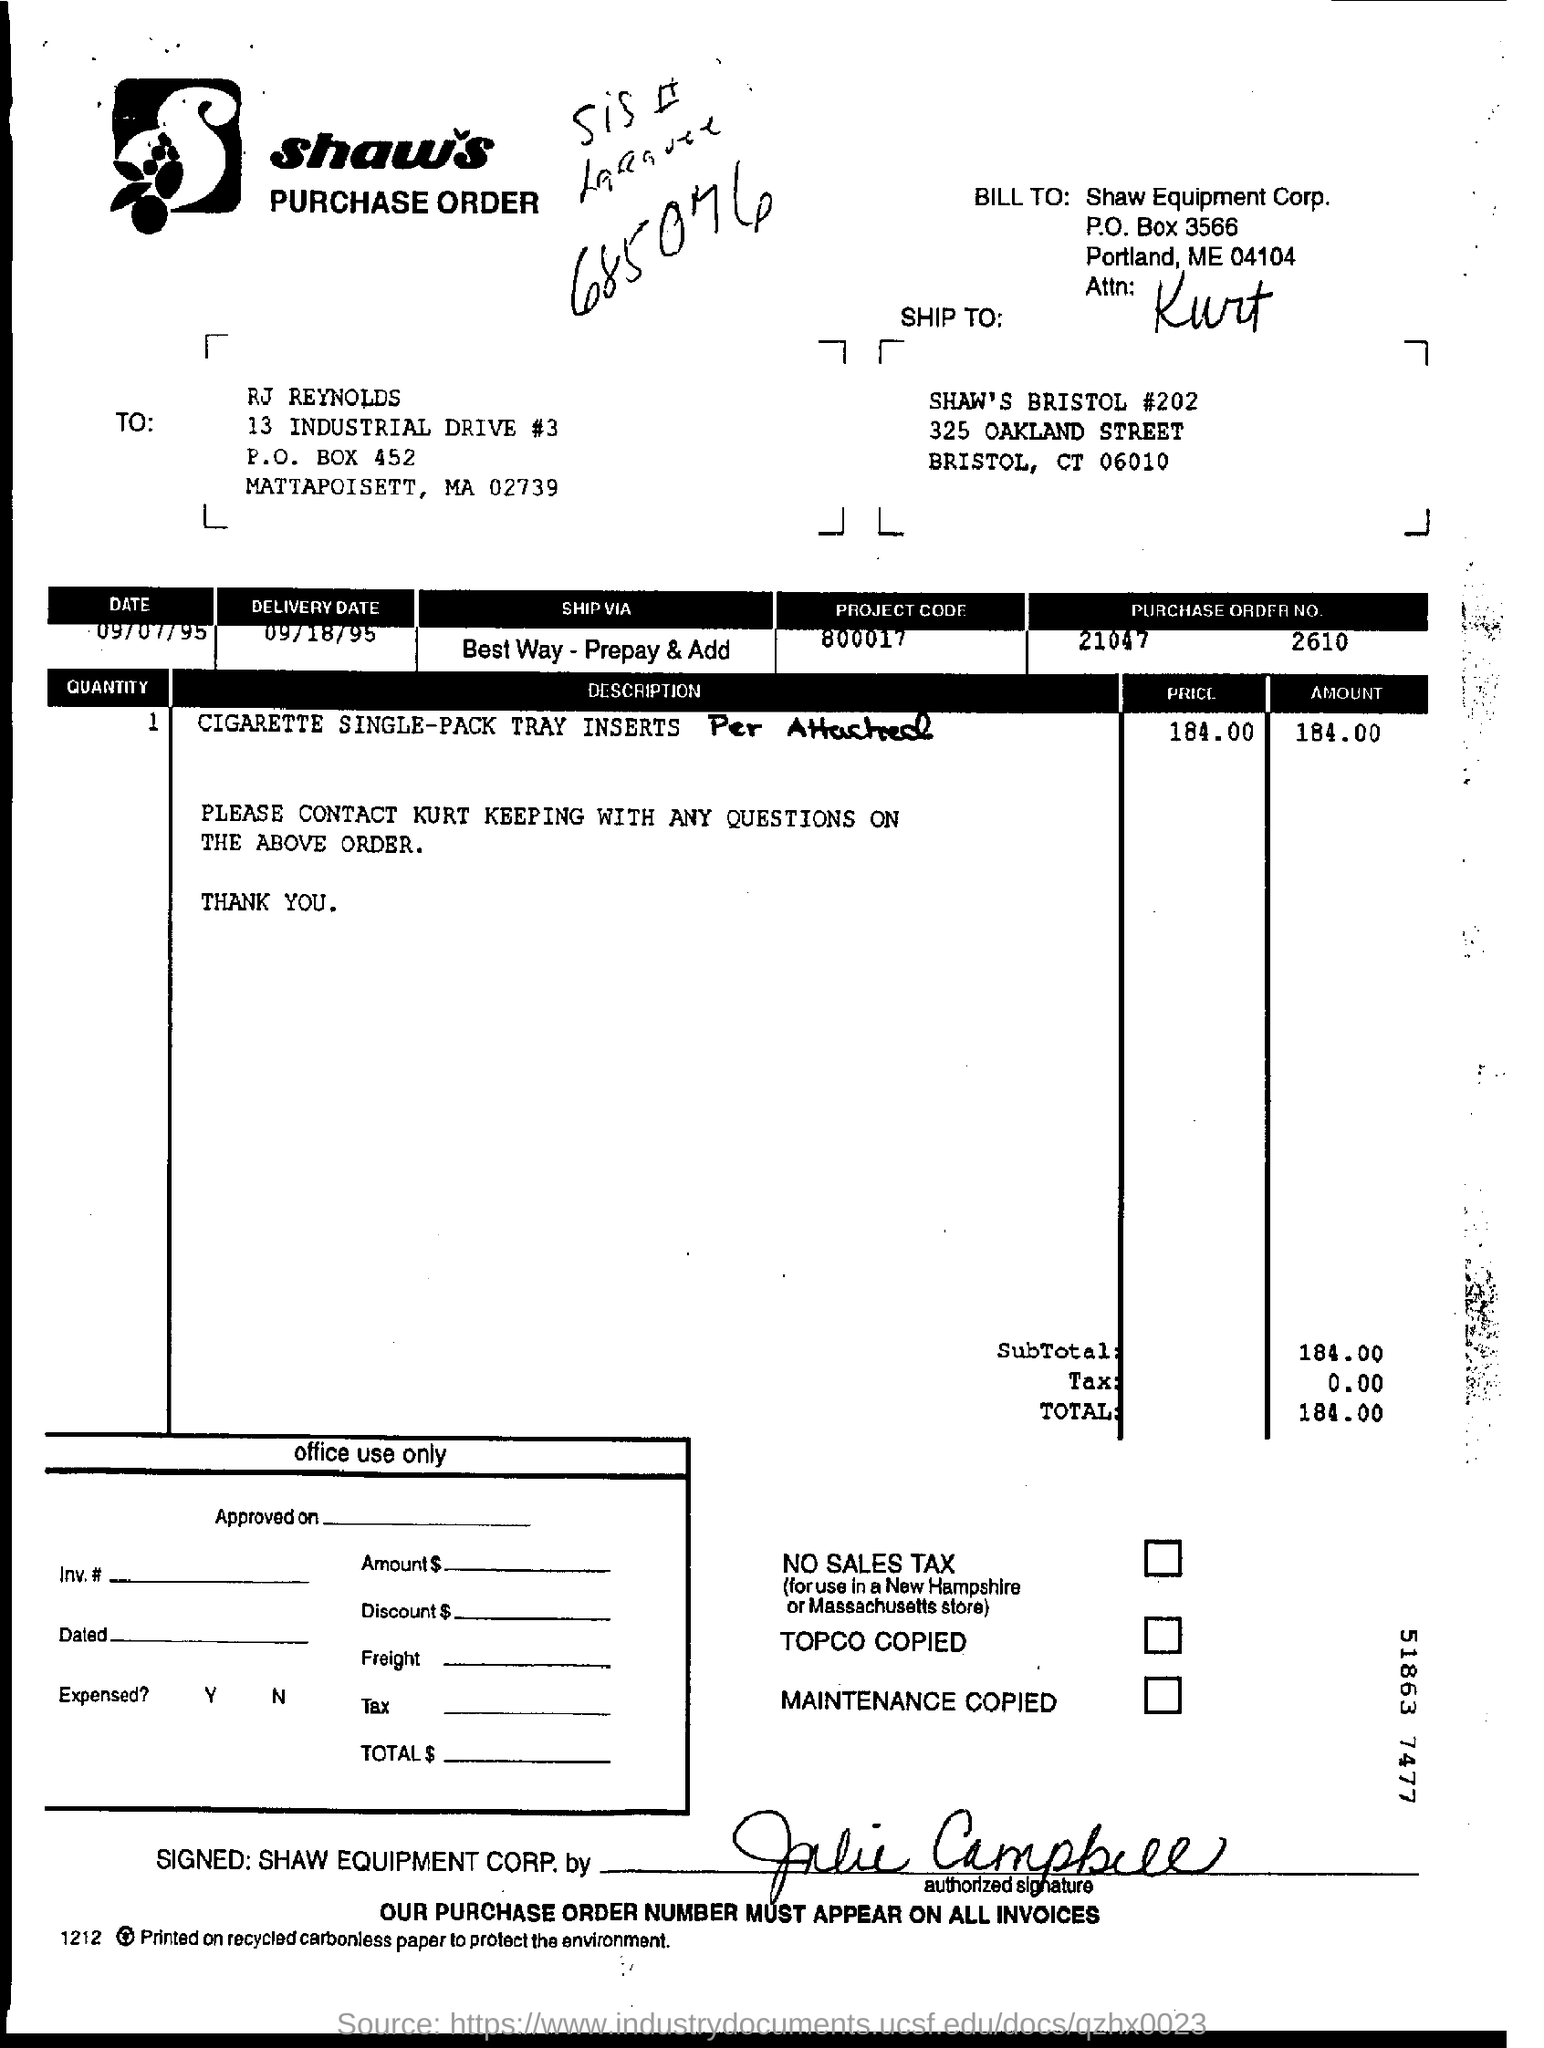What is the delivery date?
Give a very brief answer. 09/18/95. What is the purchase order number?
Provide a short and direct response. 21047     2610. 